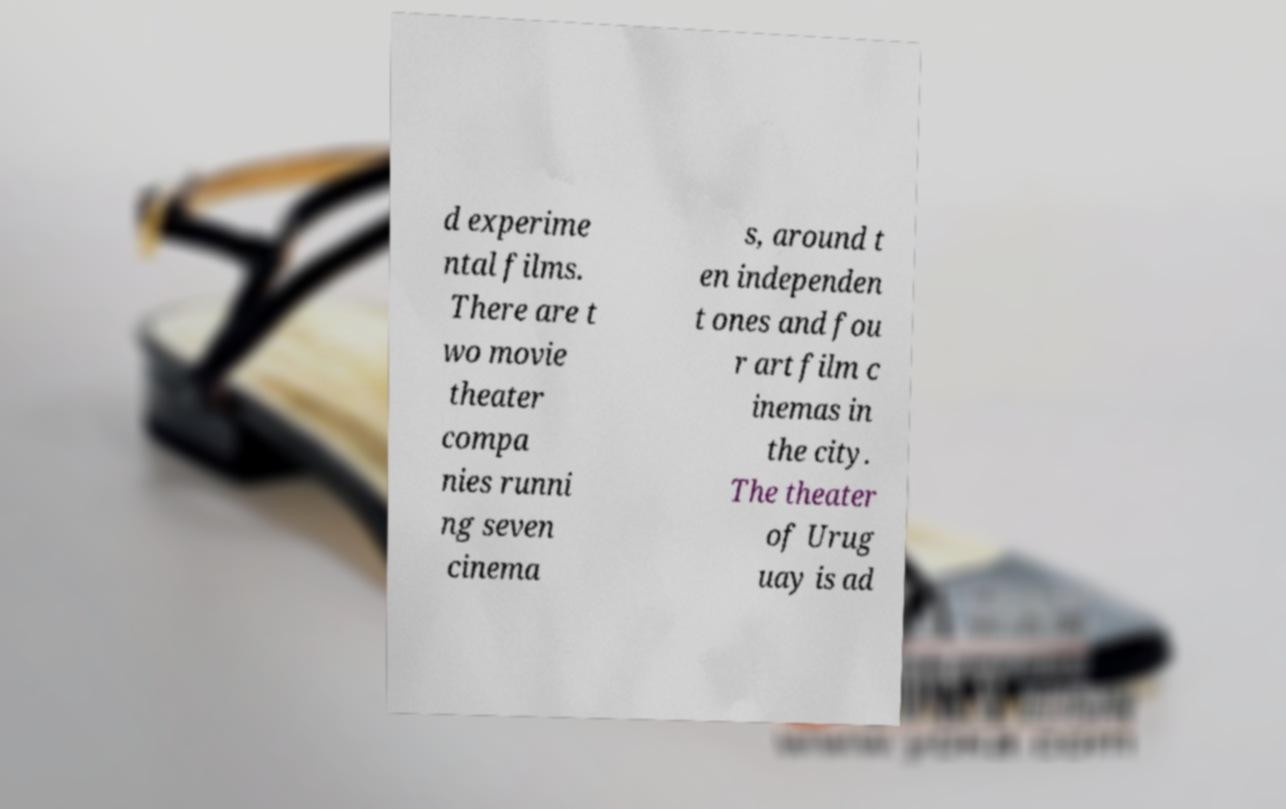Please identify and transcribe the text found in this image. d experime ntal films. There are t wo movie theater compa nies runni ng seven cinema s, around t en independen t ones and fou r art film c inemas in the city. The theater of Urug uay is ad 